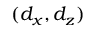<formula> <loc_0><loc_0><loc_500><loc_500>( d _ { x } , d _ { z } )</formula> 